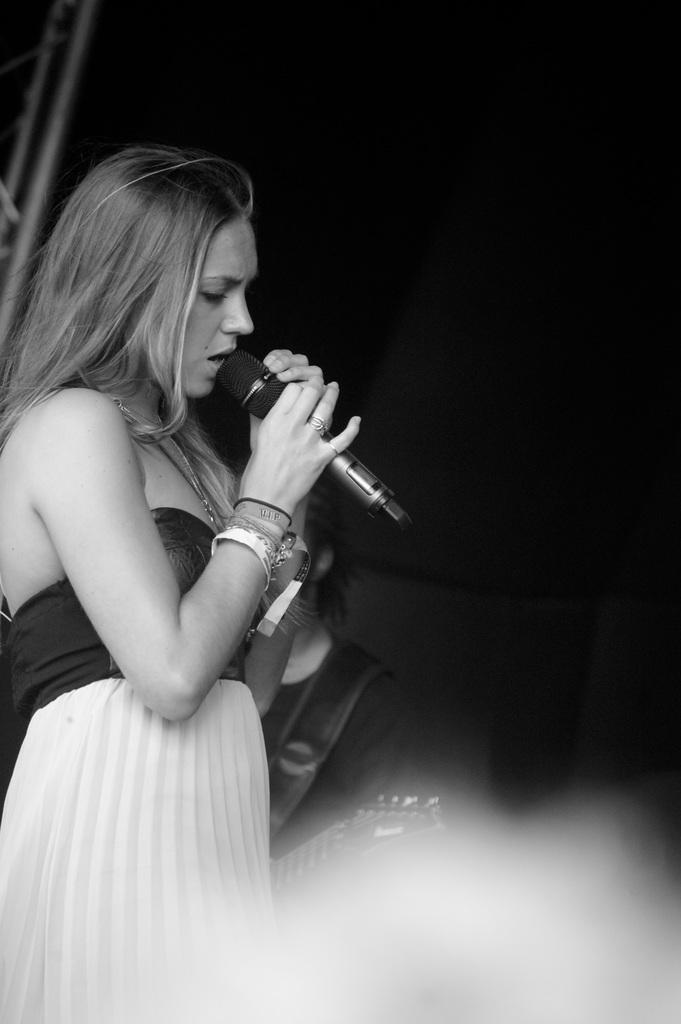What is the woman in the image doing? The woman is singing in the image. What is the woman holding while singing? The woman is holding a mic. Can you describe the person in the background of the image? The person in the background is holding a guitar. What is the color of the background in the image? The background of the image is dark. What type of government is being discussed in the image? There is no discussion of government in the image; it features a woman singing and a person playing a guitar. What emotion does the plant in the image display? There is no plant present in the image, so it cannot display any emotion. 